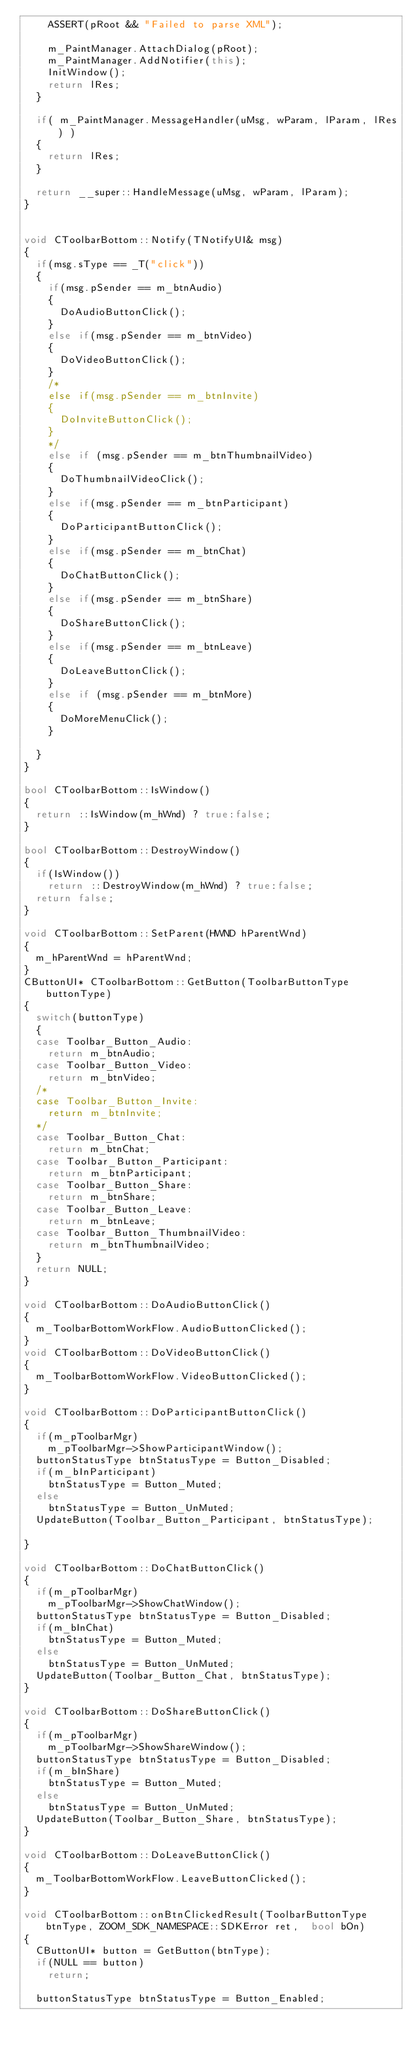<code> <loc_0><loc_0><loc_500><loc_500><_C++_>		ASSERT(pRoot && "Failed to parse XML");

		m_PaintManager.AttachDialog(pRoot);
		m_PaintManager.AddNotifier(this);
		InitWindow(); 
		return lRes;
	}

	if( m_PaintManager.MessageHandler(uMsg, wParam, lParam, lRes) ) 
	{
		return lRes;
	}

	return __super::HandleMessage(uMsg, wParam, lParam);
}


void CToolbarBottom::Notify(TNotifyUI& msg)
{
	if(msg.sType == _T("click"))
	{
		if(msg.pSender == m_btnAudio)
		{
			DoAudioButtonClick();
		}
		else if(msg.pSender == m_btnVideo)
		{
			DoVideoButtonClick();
		}
		/*
		else if(msg.pSender == m_btnInvite)
		{
			DoInviteButtonClick();
		}
		*/
		else if (msg.pSender == m_btnThumbnailVideo)
		{
			DoThumbnailVideoClick();
		}
		else if(msg.pSender == m_btnParticipant)
		{
			DoParticipantButtonClick();
		}
		else if(msg.pSender == m_btnChat)
		{
			DoChatButtonClick();
		}
		else if(msg.pSender == m_btnShare)
		{
			DoShareButtonClick();
		}
		else if(msg.pSender == m_btnLeave)
		{
			DoLeaveButtonClick();
		}
		else if (msg.pSender == m_btnMore)
		{
			DoMoreMenuClick();
		}

	}
}

bool CToolbarBottom::IsWindow()
{
	return ::IsWindow(m_hWnd) ? true:false;
}

bool CToolbarBottom::DestroyWindow()
{
	if(IsWindow())
		return ::DestroyWindow(m_hWnd) ? true:false;
	return false;
}

void CToolbarBottom::SetParent(HWND hParentWnd)
{
	m_hParentWnd = hParentWnd;
}
CButtonUI* CToolbarBottom::GetButton(ToolbarButtonType buttonType)
{
	switch(buttonType)
	{
	case Toolbar_Button_Audio:
		return m_btnAudio;
	case Toolbar_Button_Video:
		return m_btnVideo;
	/*
	case Toolbar_Button_Invite:
		return m_btnInvite;
	*/
	case Toolbar_Button_Chat:
		return m_btnChat;
	case Toolbar_Button_Participant:
		return m_btnParticipant;
	case Toolbar_Button_Share:
		return m_btnShare;
	case Toolbar_Button_Leave:
		return m_btnLeave;
	case Toolbar_Button_ThumbnailVideo:
		return m_btnThumbnailVideo;
	}
	return NULL;
}

void CToolbarBottom::DoAudioButtonClick()
{
	m_ToolbarBottomWorkFlow.AudioButtonClicked();
}
void CToolbarBottom::DoVideoButtonClick()
{
	m_ToolbarBottomWorkFlow.VideoButtonClicked();
}

void CToolbarBottom::DoParticipantButtonClick()
{
	if(m_pToolbarMgr)
		m_pToolbarMgr->ShowParticipantWindow();
	buttonStatusType btnStatusType = Button_Disabled;
	if(m_bInParticipant)
		btnStatusType = Button_Muted;
	else
		btnStatusType = Button_UnMuted;
	UpdateButton(Toolbar_Button_Participant, btnStatusType);
	
}

void CToolbarBottom::DoChatButtonClick()
{
	if(m_pToolbarMgr)
		m_pToolbarMgr->ShowChatWindow();
	buttonStatusType btnStatusType = Button_Disabled;
	if(m_bInChat)
		btnStatusType = Button_Muted;
	else
		btnStatusType = Button_UnMuted;
	UpdateButton(Toolbar_Button_Chat, btnStatusType);
}

void CToolbarBottom::DoShareButtonClick()
{
	if(m_pToolbarMgr)
		m_pToolbarMgr->ShowShareWindow();
	buttonStatusType btnStatusType = Button_Disabled;
	if(m_bInShare)
		btnStatusType = Button_Muted;
	else
		btnStatusType = Button_UnMuted;
	UpdateButton(Toolbar_Button_Share, btnStatusType);
}

void CToolbarBottom::DoLeaveButtonClick()
{
	m_ToolbarBottomWorkFlow.LeaveButtonClicked();
}

void CToolbarBottom::onBtnClickedResult(ToolbarButtonType btnType, ZOOM_SDK_NAMESPACE::SDKError ret,  bool bOn)
{
	CButtonUI* button = GetButton(btnType);
	if(NULL == button)
		return;

	buttonStatusType btnStatusType = Button_Enabled;</code> 